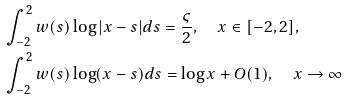Convert formula to latex. <formula><loc_0><loc_0><loc_500><loc_500>& \int _ { - 2 } ^ { 2 } w ( s ) \log | x - s | d s = \frac { \varsigma } { 2 } , \quad x \in [ - 2 , 2 ] , \\ & \int _ { - 2 } ^ { 2 } w ( s ) \log ( x - s ) d s = \log x + O ( 1 ) , \quad x \rightarrow \infty</formula> 